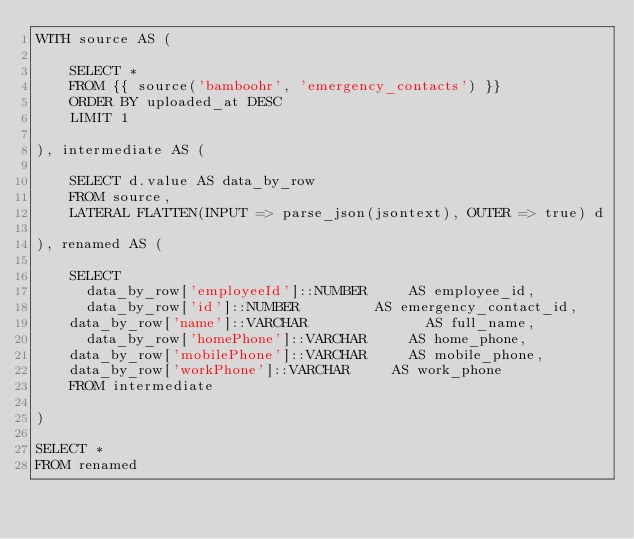Convert code to text. <code><loc_0><loc_0><loc_500><loc_500><_SQL_>WITH source AS (

    SELECT *
    FROM {{ source('bamboohr', 'emergency_contacts') }}
    ORDER BY uploaded_at DESC
    LIMIT 1

), intermediate AS (

    SELECT d.value AS data_by_row
    FROM source,
    LATERAL FLATTEN(INPUT => parse_json(jsontext), OUTER => true) d
  
), renamed AS (

    SELECT
      data_by_row['employeeId']::NUMBER 		AS employee_id,
      data_by_row['id']::NUMBER 				AS emergency_contact_id,
	  data_by_row['name']::VARCHAR 	            AS full_name,
      data_by_row['homePhone']::VARCHAR 		AS home_phone,
	  data_by_row['mobilePhone']::VARCHAR 		AS mobile_phone,
	  data_by_row['workPhone']::VARCHAR			AS work_phone
    FROM intermediate

)

SELECT *
FROM renamed
</code> 